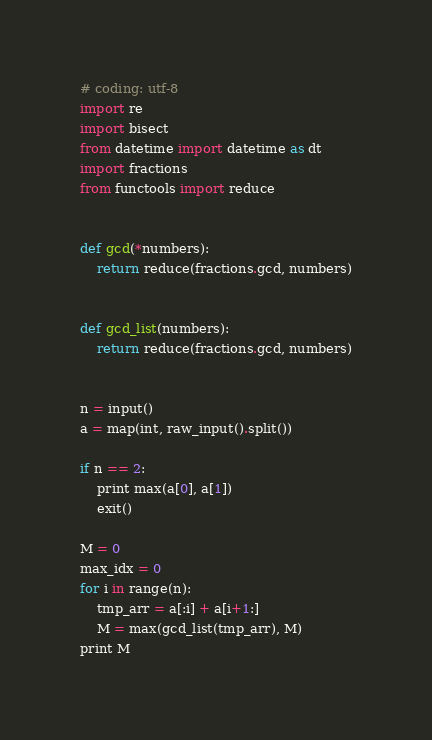<code> <loc_0><loc_0><loc_500><loc_500><_Python_># coding: utf-8
import re
import bisect
from datetime import datetime as dt
import fractions
from functools import reduce


def gcd(*numbers):
    return reduce(fractions.gcd, numbers)


def gcd_list(numbers):
    return reduce(fractions.gcd, numbers)


n = input()
a = map(int, raw_input().split())

if n == 2:
    print max(a[0], a[1])
    exit()

M = 0
max_idx = 0
for i in range(n):
    tmp_arr = a[:i] + a[i+1:]
    M = max(gcd_list(tmp_arr), M)
print M
</code> 